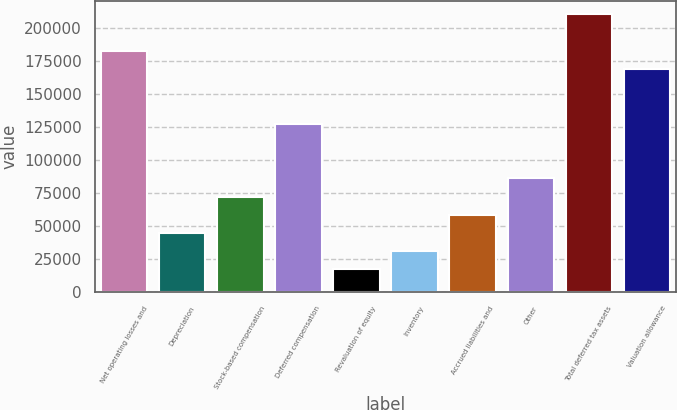Convert chart to OTSL. <chart><loc_0><loc_0><loc_500><loc_500><bar_chart><fcel>Net operating losses and<fcel>Depreciation<fcel>Stock-based compensation<fcel>Deferred compensation<fcel>Revaluation of equity<fcel>Inventory<fcel>Accrued liabilities and<fcel>Other<fcel>Total deferred tax assets<fcel>Valuation allowance<nl><fcel>182624<fcel>44754.7<fcel>72328.5<fcel>127476<fcel>17180.9<fcel>30967.8<fcel>58541.6<fcel>86115.4<fcel>210198<fcel>168837<nl></chart> 